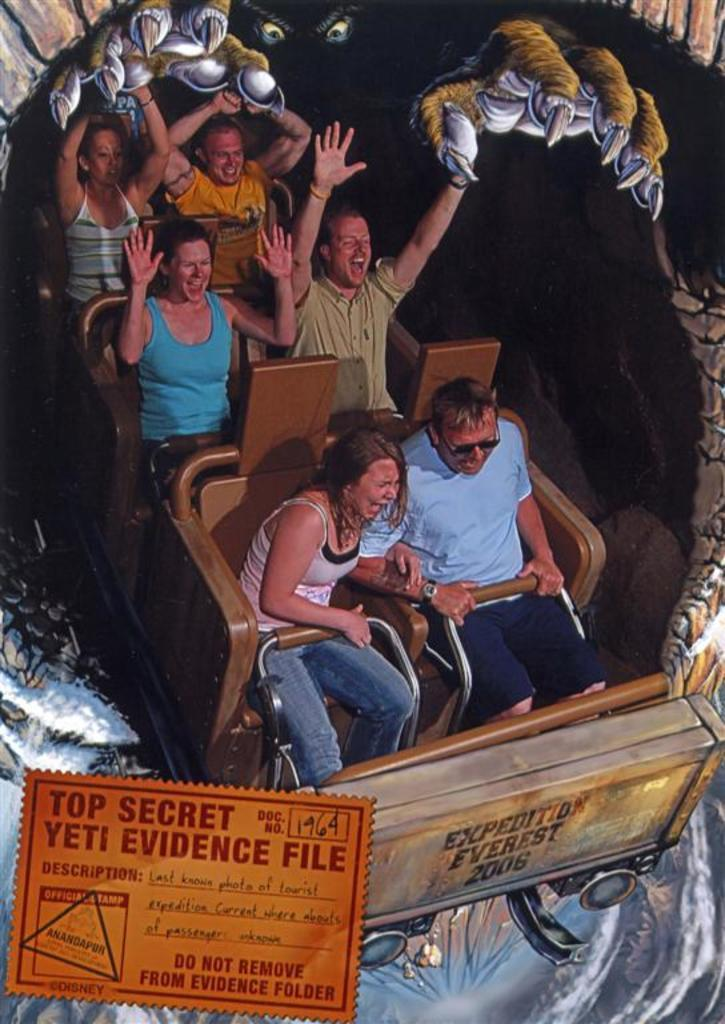What is the main subject in the center of the image? There are people sitting in the center of the image. What is written or displayed at the bottom of the image? There is some text at the bottom of the image. Where is the cactus located in the image? There is no cactus present in the image. What type of war is being depicted in the image? There is no war being depicted in the image; it features people sitting in the center. 